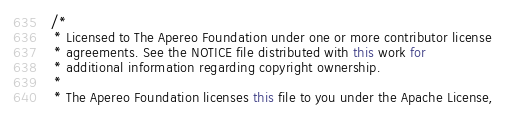Convert code to text. <code><loc_0><loc_0><loc_500><loc_500><_Java_>/*
 * Licensed to The Apereo Foundation under one or more contributor license
 * agreements. See the NOTICE file distributed with this work for
 * additional information regarding copyright ownership.
 *
 * The Apereo Foundation licenses this file to you under the Apache License,</code> 